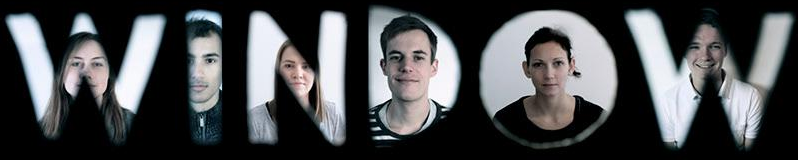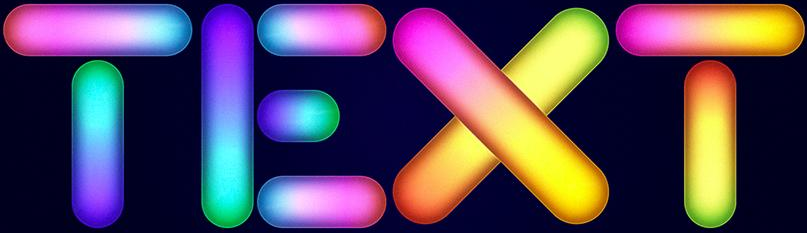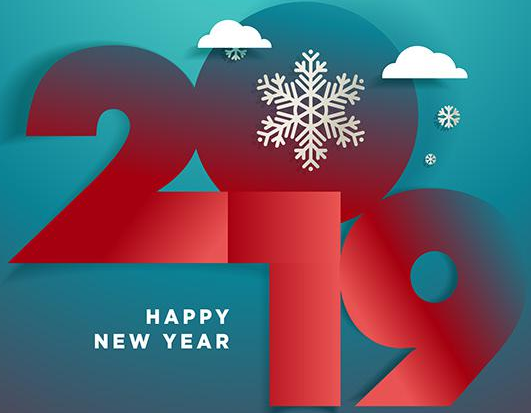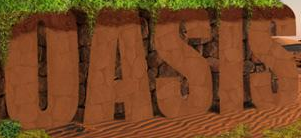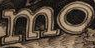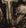Read the text content from these images in order, separated by a semicolon. WINDOW; TEXT; 2019; OASIS; mo; # 